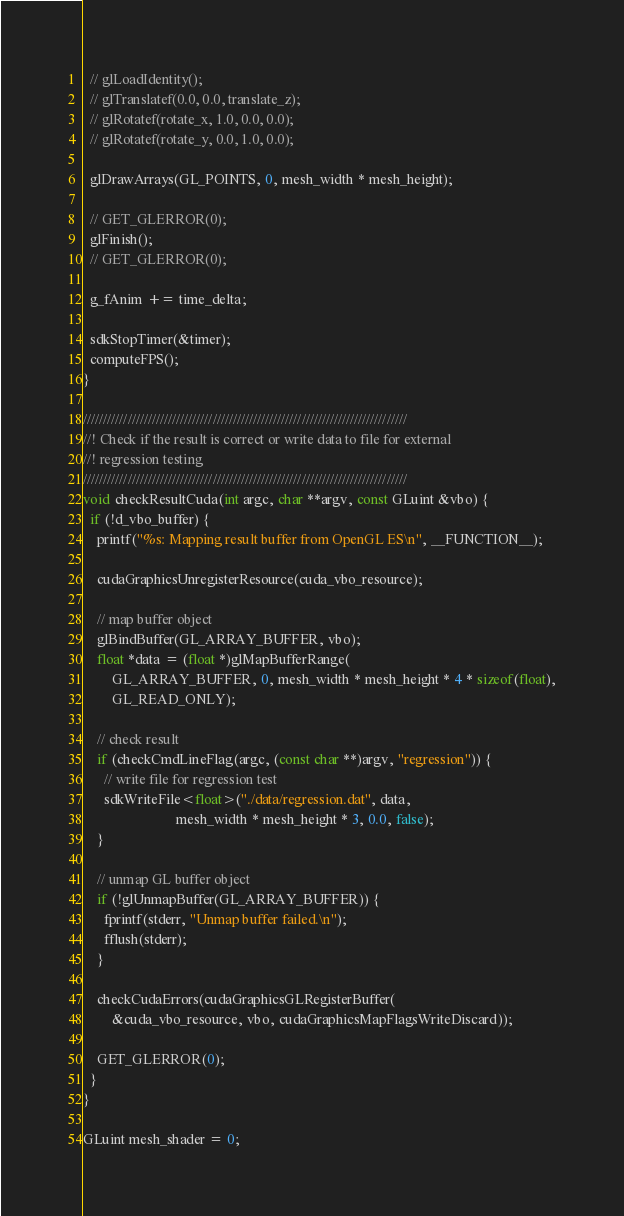Convert code to text. <code><loc_0><loc_0><loc_500><loc_500><_Cuda_>  // glLoadIdentity();
  // glTranslatef(0.0, 0.0, translate_z);
  // glRotatef(rotate_x, 1.0, 0.0, 0.0);
  // glRotatef(rotate_y, 0.0, 1.0, 0.0);

  glDrawArrays(GL_POINTS, 0, mesh_width * mesh_height);

  // GET_GLERROR(0);
  glFinish();
  // GET_GLERROR(0);

  g_fAnim += time_delta;

  sdkStopTimer(&timer);
  computeFPS();
}

////////////////////////////////////////////////////////////////////////////////
//! Check if the result is correct or write data to file for external
//! regression testing
////////////////////////////////////////////////////////////////////////////////
void checkResultCuda(int argc, char **argv, const GLuint &vbo) {
  if (!d_vbo_buffer) {
    printf("%s: Mapping result buffer from OpenGL ES\n", __FUNCTION__);

    cudaGraphicsUnregisterResource(cuda_vbo_resource);

    // map buffer object
    glBindBuffer(GL_ARRAY_BUFFER, vbo);
    float *data = (float *)glMapBufferRange(
        GL_ARRAY_BUFFER, 0, mesh_width * mesh_height * 4 * sizeof(float),
        GL_READ_ONLY);

    // check result
    if (checkCmdLineFlag(argc, (const char **)argv, "regression")) {
      // write file for regression test
      sdkWriteFile<float>("./data/regression.dat", data,
                          mesh_width * mesh_height * 3, 0.0, false);
    }

    // unmap GL buffer object
    if (!glUnmapBuffer(GL_ARRAY_BUFFER)) {
      fprintf(stderr, "Unmap buffer failed.\n");
      fflush(stderr);
    }

    checkCudaErrors(cudaGraphicsGLRegisterBuffer(
        &cuda_vbo_resource, vbo, cudaGraphicsMapFlagsWriteDiscard));

    GET_GLERROR(0);
  }
}

GLuint mesh_shader = 0;
</code> 